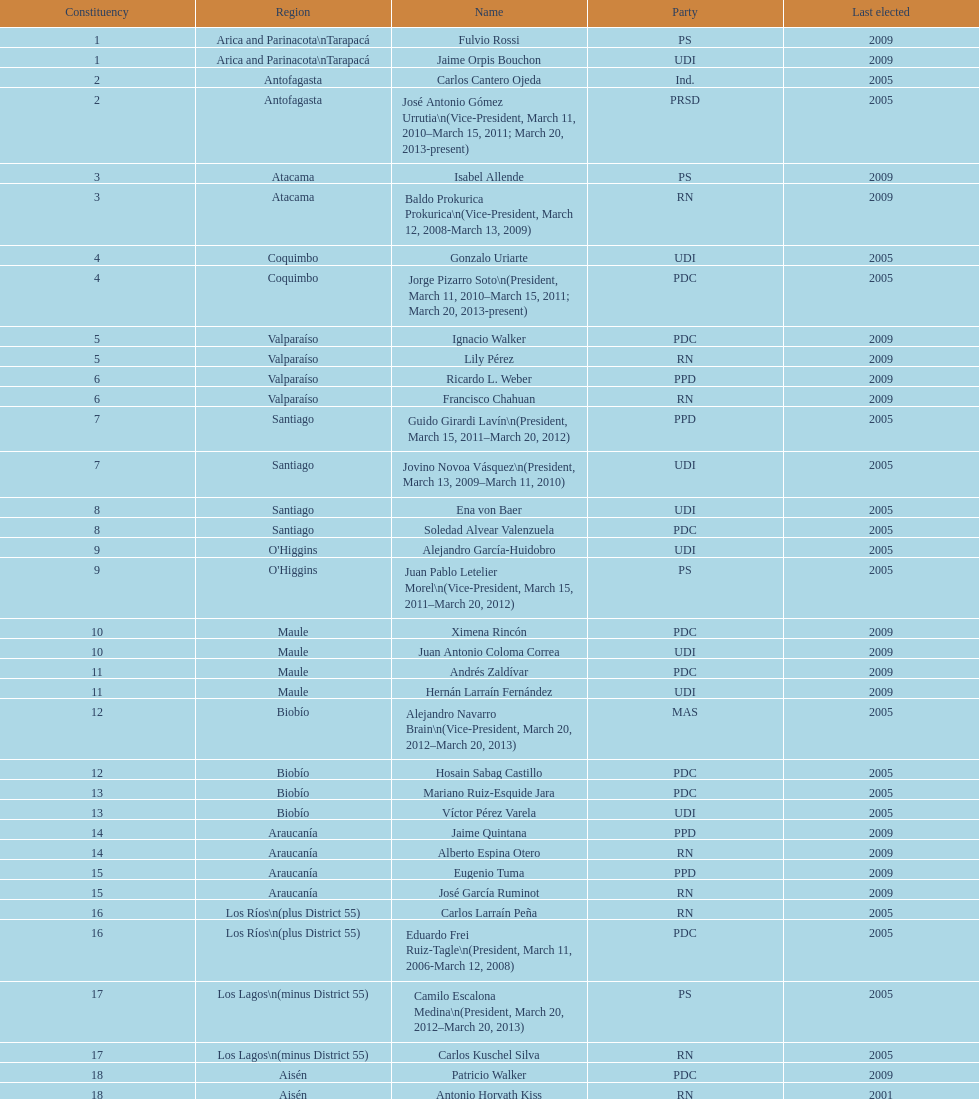Which party did jaime quintana belong to? PPD. Could you parse the entire table? {'header': ['Constituency', 'Region', 'Name', 'Party', 'Last elected'], 'rows': [['1', 'Arica and Parinacota\\nTarapacá', 'Fulvio Rossi', 'PS', '2009'], ['1', 'Arica and Parinacota\\nTarapacá', 'Jaime Orpis Bouchon', 'UDI', '2009'], ['2', 'Antofagasta', 'Carlos Cantero Ojeda', 'Ind.', '2005'], ['2', 'Antofagasta', 'José Antonio Gómez Urrutia\\n(Vice-President, March 11, 2010–March 15, 2011; March 20, 2013-present)', 'PRSD', '2005'], ['3', 'Atacama', 'Isabel Allende', 'PS', '2009'], ['3', 'Atacama', 'Baldo Prokurica Prokurica\\n(Vice-President, March 12, 2008-March 13, 2009)', 'RN', '2009'], ['4', 'Coquimbo', 'Gonzalo Uriarte', 'UDI', '2005'], ['4', 'Coquimbo', 'Jorge Pizarro Soto\\n(President, March 11, 2010–March 15, 2011; March 20, 2013-present)', 'PDC', '2005'], ['5', 'Valparaíso', 'Ignacio Walker', 'PDC', '2009'], ['5', 'Valparaíso', 'Lily Pérez', 'RN', '2009'], ['6', 'Valparaíso', 'Ricardo L. Weber', 'PPD', '2009'], ['6', 'Valparaíso', 'Francisco Chahuan', 'RN', '2009'], ['7', 'Santiago', 'Guido Girardi Lavín\\n(President, March 15, 2011–March 20, 2012)', 'PPD', '2005'], ['7', 'Santiago', 'Jovino Novoa Vásquez\\n(President, March 13, 2009–March 11, 2010)', 'UDI', '2005'], ['8', 'Santiago', 'Ena von Baer', 'UDI', '2005'], ['8', 'Santiago', 'Soledad Alvear Valenzuela', 'PDC', '2005'], ['9', "O'Higgins", 'Alejandro García-Huidobro', 'UDI', '2005'], ['9', "O'Higgins", 'Juan Pablo Letelier Morel\\n(Vice-President, March 15, 2011–March 20, 2012)', 'PS', '2005'], ['10', 'Maule', 'Ximena Rincón', 'PDC', '2009'], ['10', 'Maule', 'Juan Antonio Coloma Correa', 'UDI', '2009'], ['11', 'Maule', 'Andrés Zaldívar', 'PDC', '2009'], ['11', 'Maule', 'Hernán Larraín Fernández', 'UDI', '2009'], ['12', 'Biobío', 'Alejandro Navarro Brain\\n(Vice-President, March 20, 2012–March 20, 2013)', 'MAS', '2005'], ['12', 'Biobío', 'Hosain Sabag Castillo', 'PDC', '2005'], ['13', 'Biobío', 'Mariano Ruiz-Esquide Jara', 'PDC', '2005'], ['13', 'Biobío', 'Víctor Pérez Varela', 'UDI', '2005'], ['14', 'Araucanía', 'Jaime Quintana', 'PPD', '2009'], ['14', 'Araucanía', 'Alberto Espina Otero', 'RN', '2009'], ['15', 'Araucanía', 'Eugenio Tuma', 'PPD', '2009'], ['15', 'Araucanía', 'José García Ruminot', 'RN', '2009'], ['16', 'Los Ríos\\n(plus District 55)', 'Carlos Larraín Peña', 'RN', '2005'], ['16', 'Los Ríos\\n(plus District 55)', 'Eduardo Frei Ruiz-Tagle\\n(President, March 11, 2006-March 12, 2008)', 'PDC', '2005'], ['17', 'Los Lagos\\n(minus District 55)', 'Camilo Escalona Medina\\n(President, March 20, 2012–March 20, 2013)', 'PS', '2005'], ['17', 'Los Lagos\\n(minus District 55)', 'Carlos Kuschel Silva', 'RN', '2005'], ['18', 'Aisén', 'Patricio Walker', 'PDC', '2009'], ['18', 'Aisén', 'Antonio Horvath Kiss', 'RN', '2001'], ['19', 'Magallanes', 'Carlos Bianchi Chelech\\n(Vice-President, March 13, 2009–March 11, 2010)', 'Ind.', '2005'], ['19', 'Magallanes', 'Pedro Muñoz Aburto', 'PS', '2005']]} 